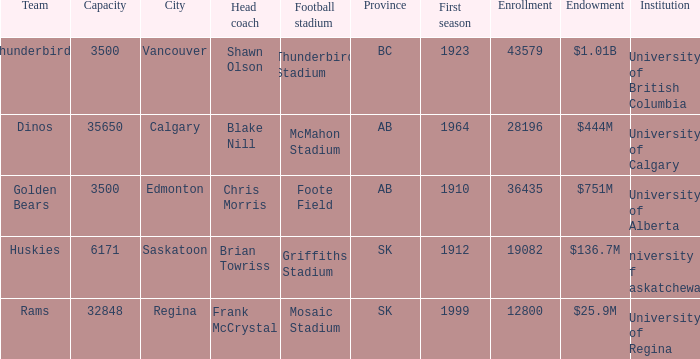How many endowments does Mosaic Stadium have? 1.0. 